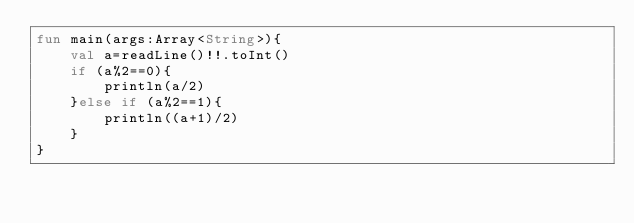<code> <loc_0><loc_0><loc_500><loc_500><_Kotlin_>fun main(args:Array<String>){
    val a=readLine()!!.toInt()
    if (a%2==0){
        println(a/2)
    }else if (a%2==1){
        println((a+1)/2)
    }
}</code> 